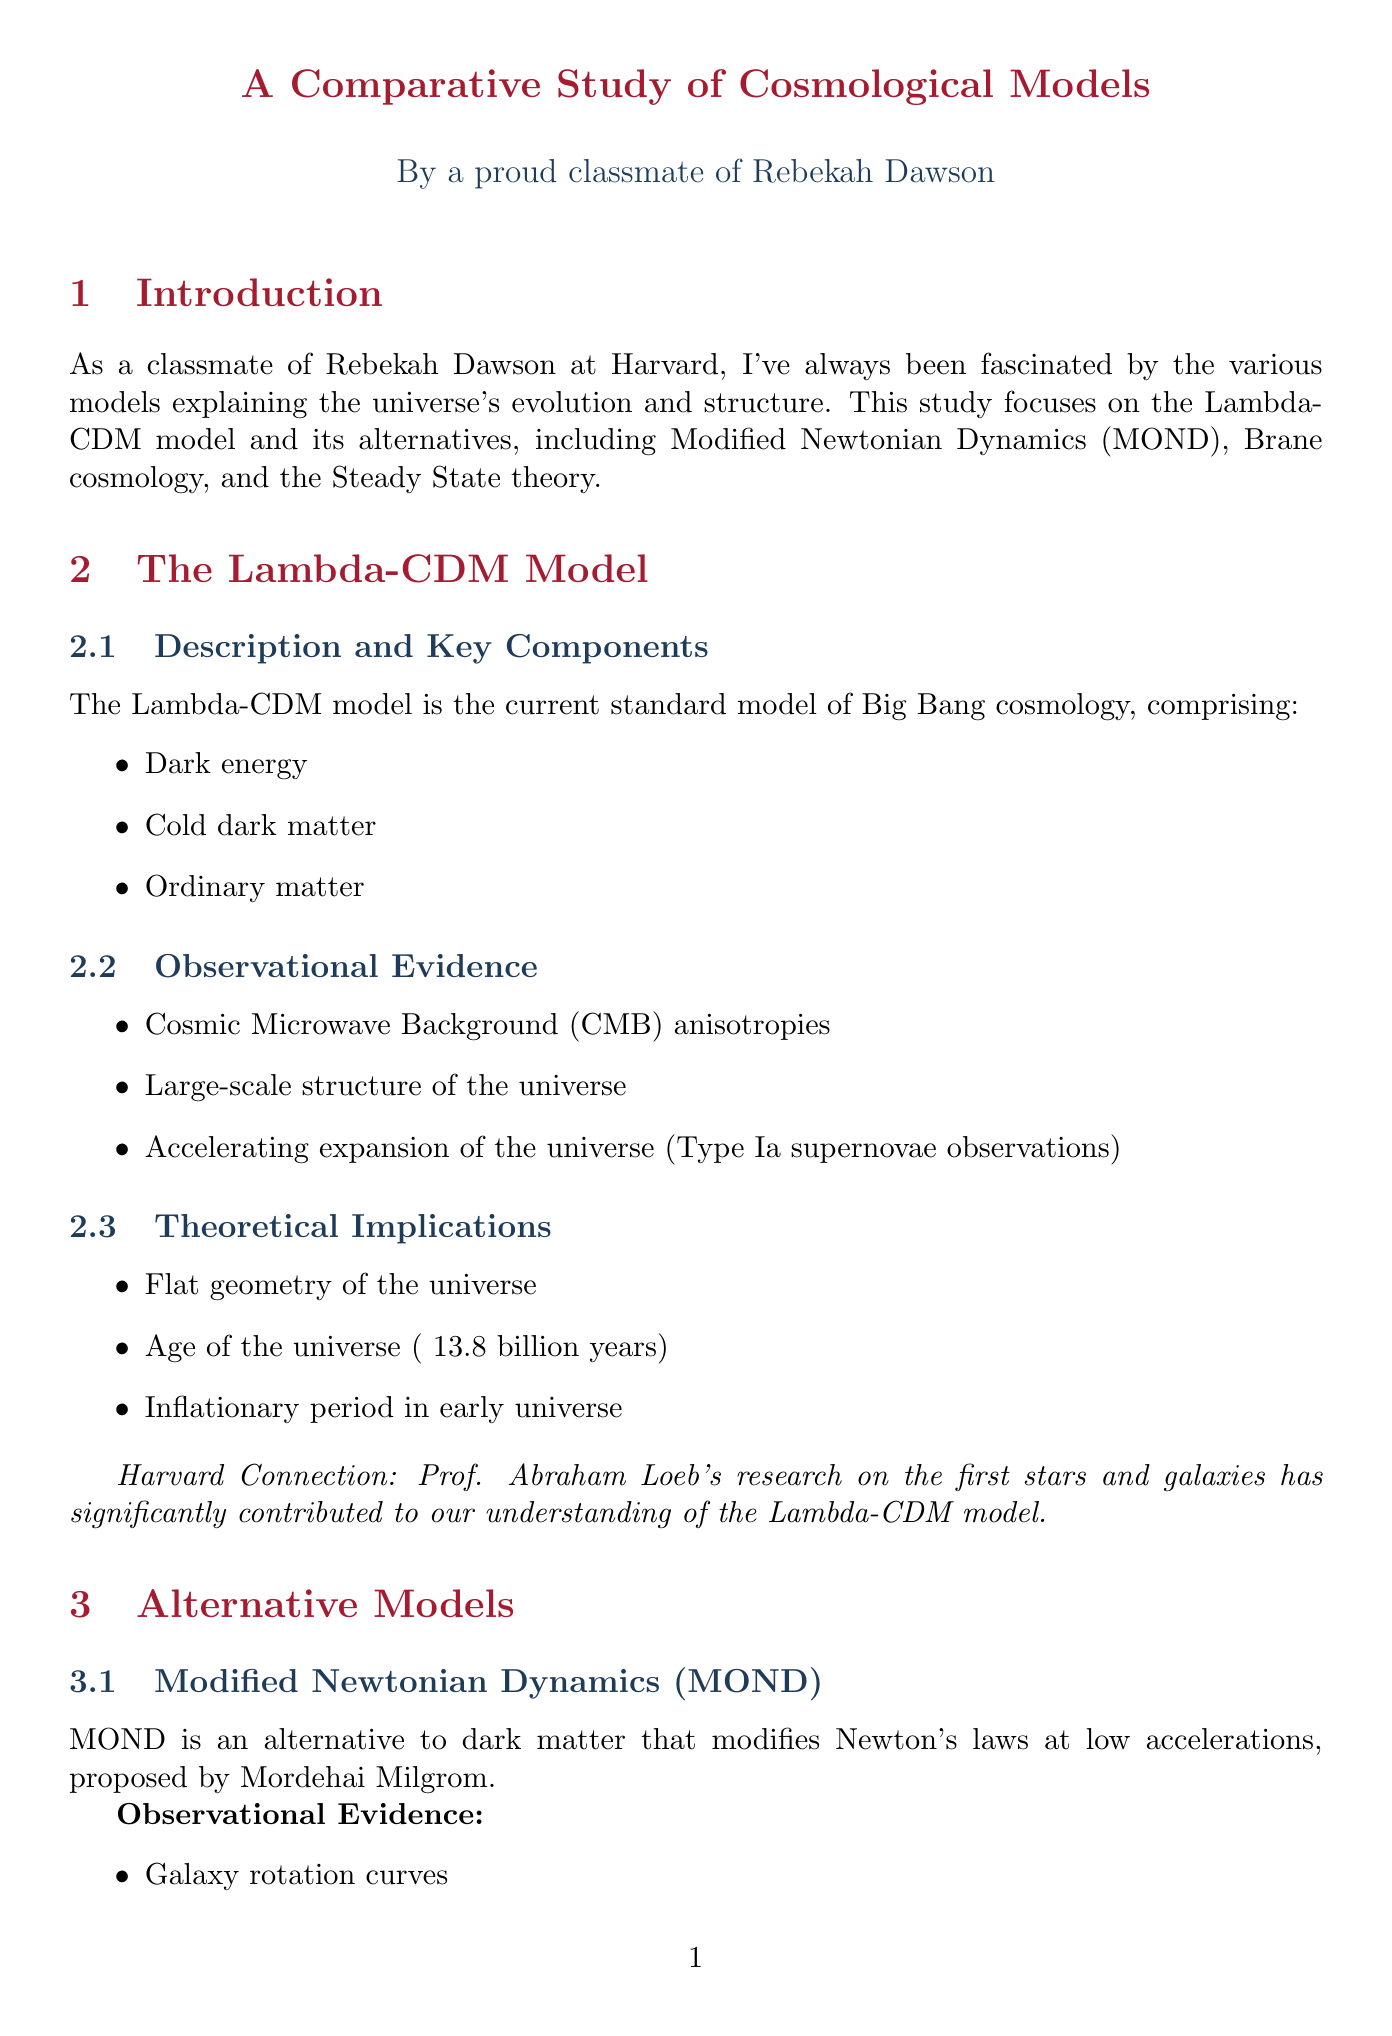What are the key models discussed in the report? The report discusses several key models including the Lambda-CDM model, Modified Newtonian Dynamics (MOND), Brane cosmology, and Steady State theory.
Answer: Lambda-CDM, MOND, Brane cosmology, Steady State theory Who proposed Modified Newtonian Dynamics (MOND)? MOND is attributed to a key proponent, Mordehai Milgrom, as mentioned in the document.
Answer: Mordehai Milgrom What observational evidence supports the Lambda-CDM model? Specific observational evidence for the Lambda-CDM model is provided including Cosmic Microwave Background (CMB) anisotropies, Large-scale structure of the universe, and Type Ia supernovae observations.
Answer: CMB anisotropies, Large-scale structure, Type Ia supernovae observations What theoretical challenge is associated with understanding dark energy? One of the theoretical challenges discussed relates to the nature of dark energy, emphasizing the need to understand the physical nature of the force causing cosmic acceleration.
Answer: Nature of dark energy Which instruments are used in Cosmic Microwave Background studies? The document lists two main instruments utilized for Cosmic Microwave Background studies, which are the Planck satellite and WMAP.
Answer: Planck satellite, WMAP What is the significance of Type Ia supernovae observations? The document mentions the significance of Type Ia supernovae observations as providing evidence for the accelerating expansion of the universe.
Answer: Evidence for accelerating expansion 